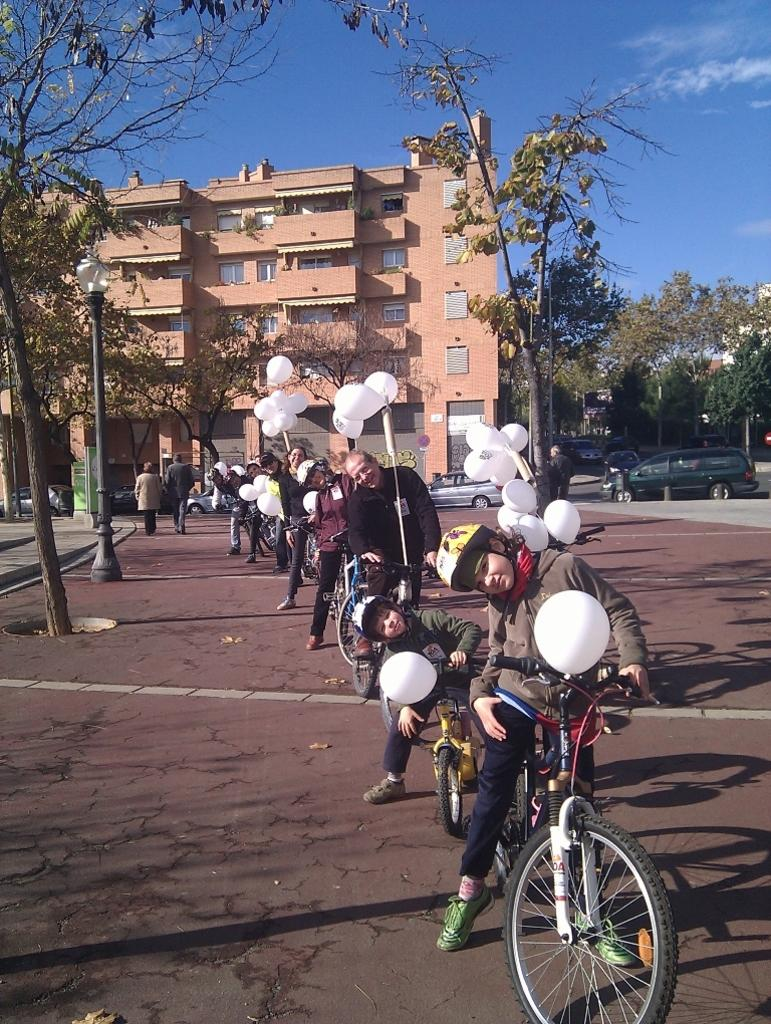Who or what is present in the image? There are people in the image. What are the people doing in the image? The people are sitting on bicycles. What can be seen in the background of the image? There is a building and trees in the background of the image. What type of cloth is being used to promote peace in the image? There is no cloth or promotion of peace present in the image; it features people sitting on bicycles with a background of a building and trees. 